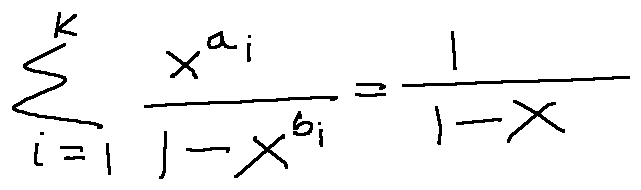<formula> <loc_0><loc_0><loc_500><loc_500>\sum \lim i t s _ { i = 1 } ^ { k } \frac { x ^ { a _ { i } } } { 1 - x ^ { b _ { i } } } = \frac { 1 } { 1 - x }</formula> 